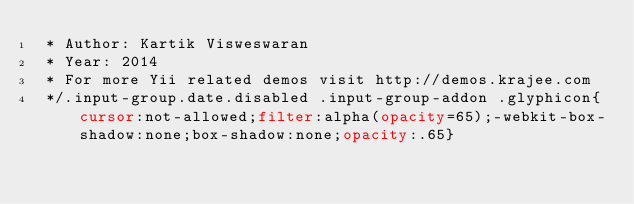Convert code to text. <code><loc_0><loc_0><loc_500><loc_500><_CSS_> * Author: Kartik Visweswaran
 * Year: 2014
 * For more Yii related demos visit http://demos.krajee.com
 */.input-group.date.disabled .input-group-addon .glyphicon{cursor:not-allowed;filter:alpha(opacity=65);-webkit-box-shadow:none;box-shadow:none;opacity:.65}</code> 